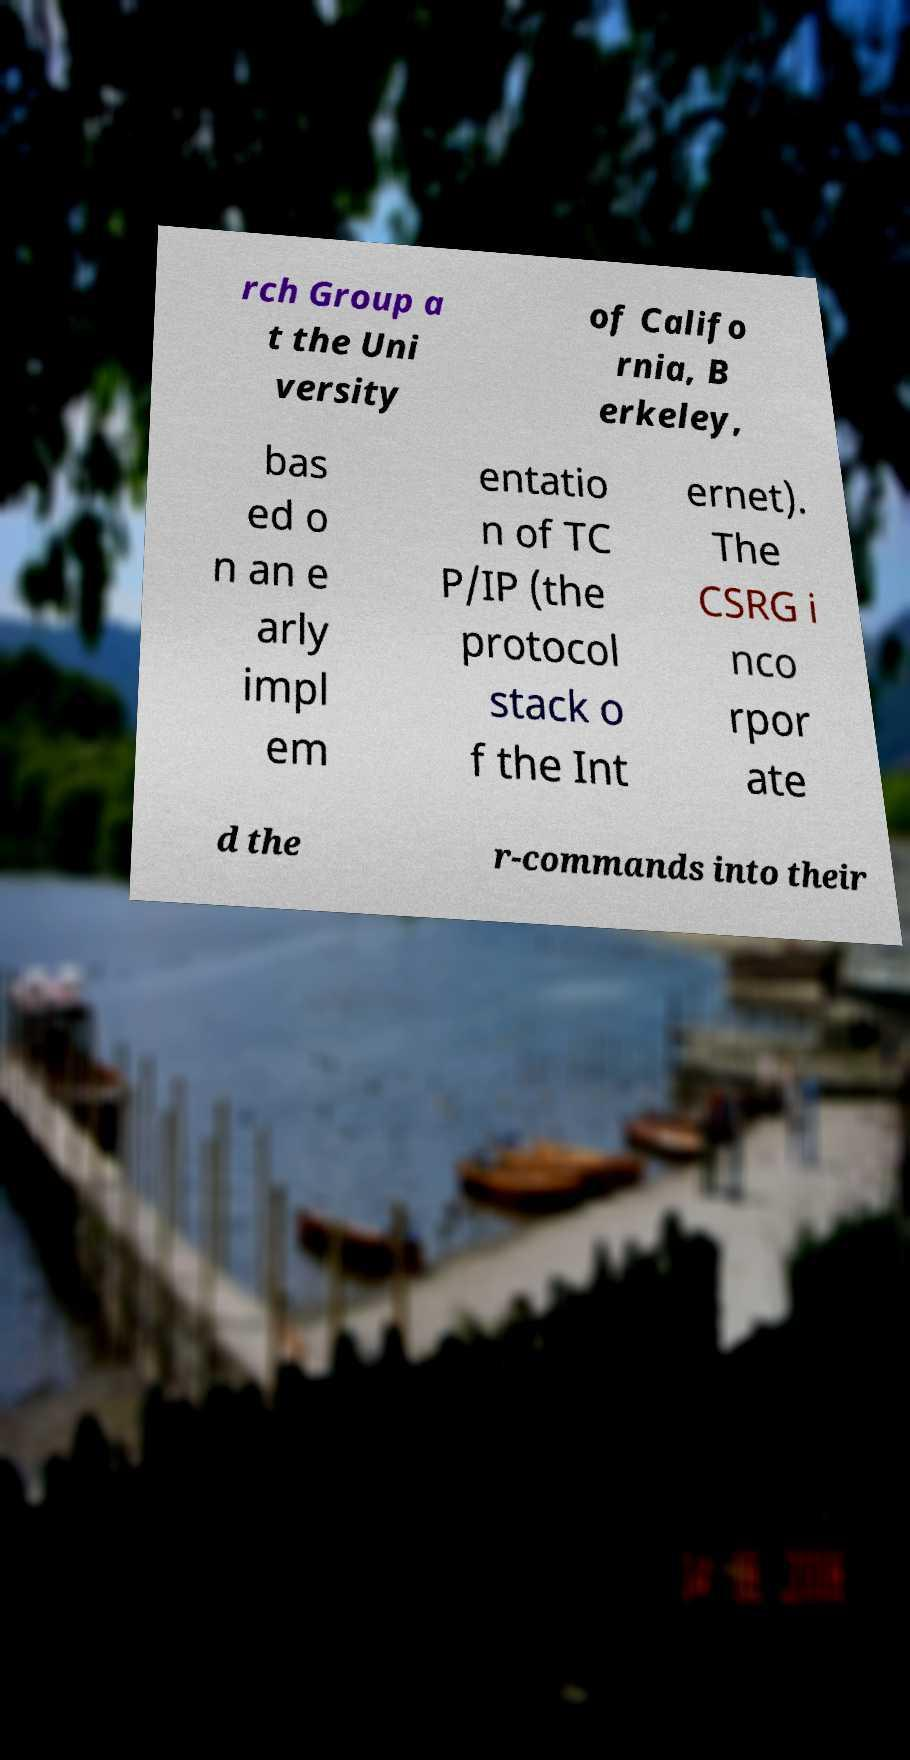Could you assist in decoding the text presented in this image and type it out clearly? rch Group a t the Uni versity of Califo rnia, B erkeley, bas ed o n an e arly impl em entatio n of TC P/IP (the protocol stack o f the Int ernet). The CSRG i nco rpor ate d the r-commands into their 